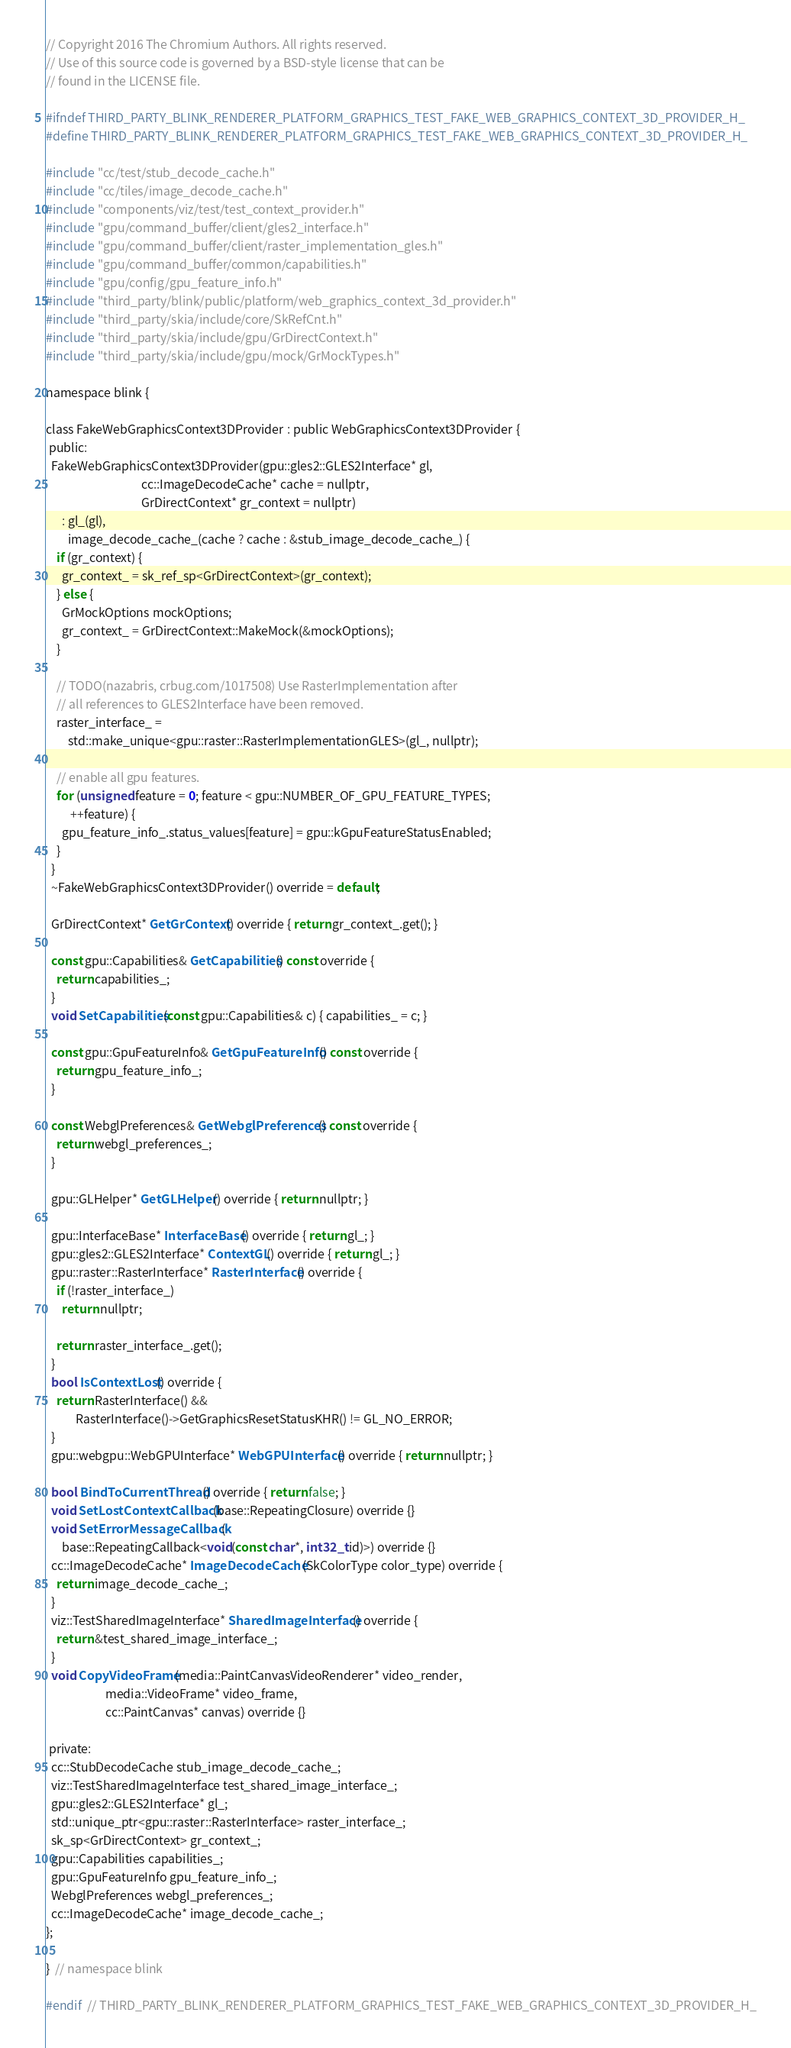Convert code to text. <code><loc_0><loc_0><loc_500><loc_500><_C_>// Copyright 2016 The Chromium Authors. All rights reserved.
// Use of this source code is governed by a BSD-style license that can be
// found in the LICENSE file.

#ifndef THIRD_PARTY_BLINK_RENDERER_PLATFORM_GRAPHICS_TEST_FAKE_WEB_GRAPHICS_CONTEXT_3D_PROVIDER_H_
#define THIRD_PARTY_BLINK_RENDERER_PLATFORM_GRAPHICS_TEST_FAKE_WEB_GRAPHICS_CONTEXT_3D_PROVIDER_H_

#include "cc/test/stub_decode_cache.h"
#include "cc/tiles/image_decode_cache.h"
#include "components/viz/test/test_context_provider.h"
#include "gpu/command_buffer/client/gles2_interface.h"
#include "gpu/command_buffer/client/raster_implementation_gles.h"
#include "gpu/command_buffer/common/capabilities.h"
#include "gpu/config/gpu_feature_info.h"
#include "third_party/blink/public/platform/web_graphics_context_3d_provider.h"
#include "third_party/skia/include/core/SkRefCnt.h"
#include "third_party/skia/include/gpu/GrDirectContext.h"
#include "third_party/skia/include/gpu/mock/GrMockTypes.h"

namespace blink {

class FakeWebGraphicsContext3DProvider : public WebGraphicsContext3DProvider {
 public:
  FakeWebGraphicsContext3DProvider(gpu::gles2::GLES2Interface* gl,
                                   cc::ImageDecodeCache* cache = nullptr,
                                   GrDirectContext* gr_context = nullptr)
      : gl_(gl),
        image_decode_cache_(cache ? cache : &stub_image_decode_cache_) {
    if (gr_context) {
      gr_context_ = sk_ref_sp<GrDirectContext>(gr_context);
    } else {
      GrMockOptions mockOptions;
      gr_context_ = GrDirectContext::MakeMock(&mockOptions);
    }

    // TODO(nazabris, crbug.com/1017508) Use RasterImplementation after
    // all references to GLES2Interface have been removed.
    raster_interface_ =
        std::make_unique<gpu::raster::RasterImplementationGLES>(gl_, nullptr);

    // enable all gpu features.
    for (unsigned feature = 0; feature < gpu::NUMBER_OF_GPU_FEATURE_TYPES;
         ++feature) {
      gpu_feature_info_.status_values[feature] = gpu::kGpuFeatureStatusEnabled;
    }
  }
  ~FakeWebGraphicsContext3DProvider() override = default;

  GrDirectContext* GetGrContext() override { return gr_context_.get(); }

  const gpu::Capabilities& GetCapabilities() const override {
    return capabilities_;
  }
  void SetCapabilities(const gpu::Capabilities& c) { capabilities_ = c; }

  const gpu::GpuFeatureInfo& GetGpuFeatureInfo() const override {
    return gpu_feature_info_;
  }

  const WebglPreferences& GetWebglPreferences() const override {
    return webgl_preferences_;
  }

  gpu::GLHelper* GetGLHelper() override { return nullptr; }

  gpu::InterfaceBase* InterfaceBase() override { return gl_; }
  gpu::gles2::GLES2Interface* ContextGL() override { return gl_; }
  gpu::raster::RasterInterface* RasterInterface() override {
    if (!raster_interface_)
      return nullptr;

    return raster_interface_.get();
  }
  bool IsContextLost() override {
    return RasterInterface() &&
           RasterInterface()->GetGraphicsResetStatusKHR() != GL_NO_ERROR;
  }
  gpu::webgpu::WebGPUInterface* WebGPUInterface() override { return nullptr; }

  bool BindToCurrentThread() override { return false; }
  void SetLostContextCallback(base::RepeatingClosure) override {}
  void SetErrorMessageCallback(
      base::RepeatingCallback<void(const char*, int32_t id)>) override {}
  cc::ImageDecodeCache* ImageDecodeCache(SkColorType color_type) override {
    return image_decode_cache_;
  }
  viz::TestSharedImageInterface* SharedImageInterface() override {
    return &test_shared_image_interface_;
  }
  void CopyVideoFrame(media::PaintCanvasVideoRenderer* video_render,
                      media::VideoFrame* video_frame,
                      cc::PaintCanvas* canvas) override {}

 private:
  cc::StubDecodeCache stub_image_decode_cache_;
  viz::TestSharedImageInterface test_shared_image_interface_;
  gpu::gles2::GLES2Interface* gl_;
  std::unique_ptr<gpu::raster::RasterInterface> raster_interface_;
  sk_sp<GrDirectContext> gr_context_;
  gpu::Capabilities capabilities_;
  gpu::GpuFeatureInfo gpu_feature_info_;
  WebglPreferences webgl_preferences_;
  cc::ImageDecodeCache* image_decode_cache_;
};

}  // namespace blink

#endif  // THIRD_PARTY_BLINK_RENDERER_PLATFORM_GRAPHICS_TEST_FAKE_WEB_GRAPHICS_CONTEXT_3D_PROVIDER_H_
</code> 